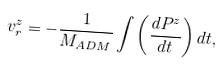<formula> <loc_0><loc_0><loc_500><loc_500>v ^ { z } _ { r } = - \frac { 1 } { M _ { A D M } } \int \left ( \frac { d P ^ { z } } { d t } \right ) d t ,</formula> 